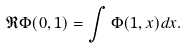<formula> <loc_0><loc_0><loc_500><loc_500>\mathfrak R \Phi ( 0 , 1 ) = \int \Phi ( 1 , x ) d x .</formula> 